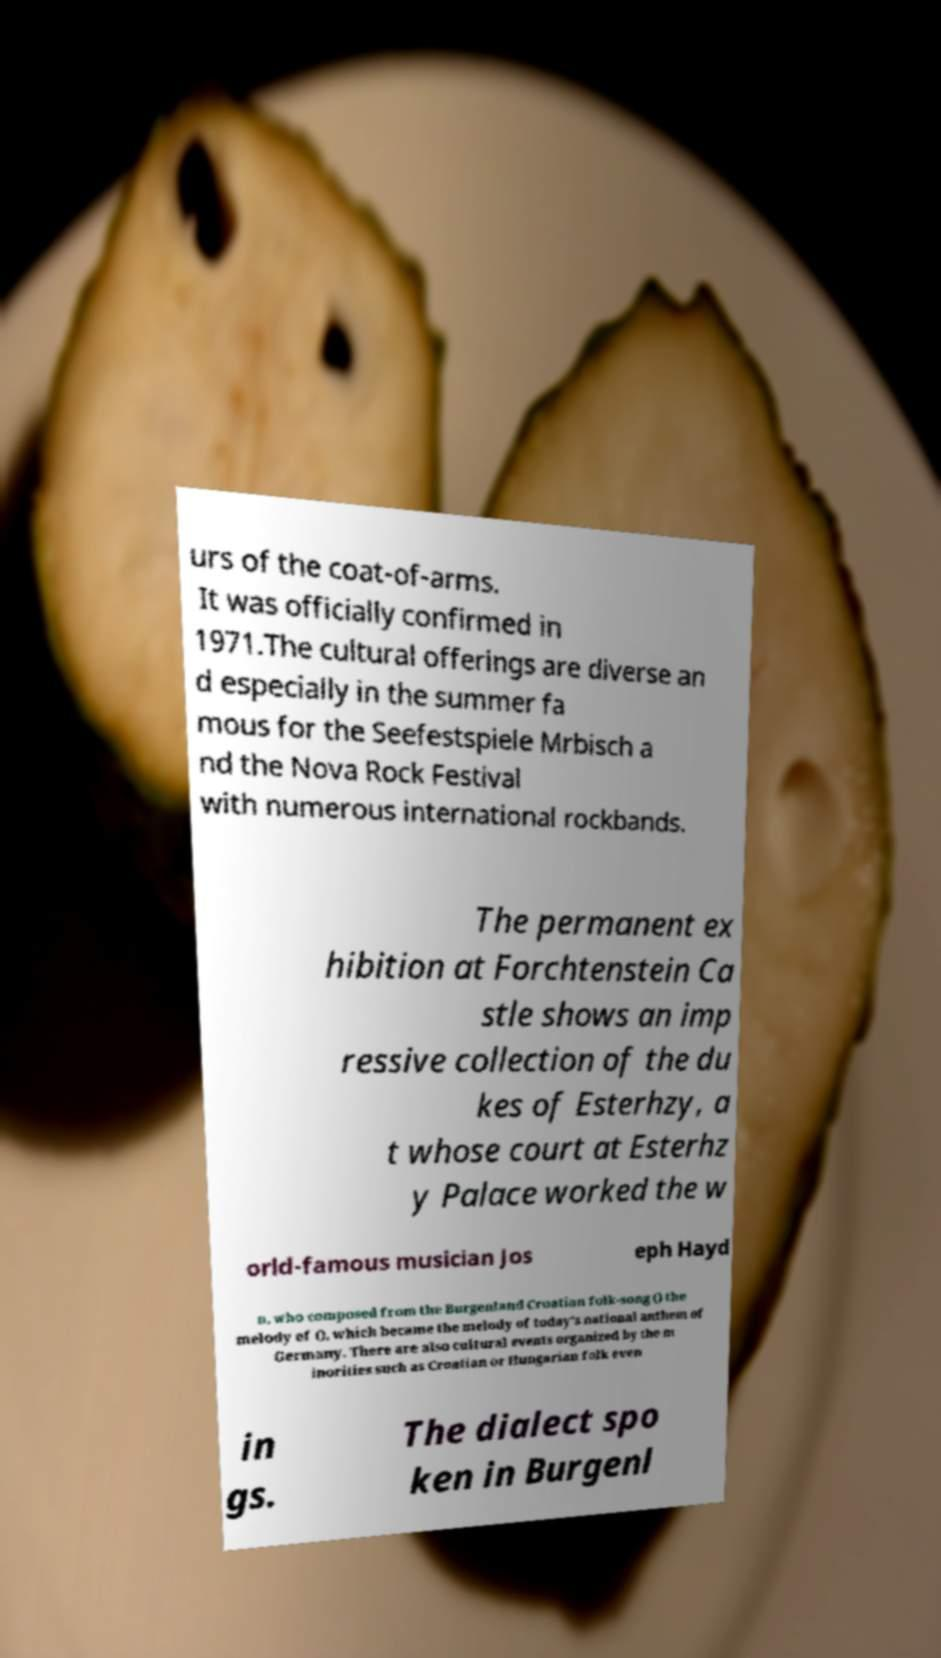For documentation purposes, I need the text within this image transcribed. Could you provide that? urs of the coat-of-arms. It was officially confirmed in 1971.The cultural offerings are diverse an d especially in the summer fa mous for the Seefestspiele Mrbisch a nd the Nova Rock Festival with numerous international rockbands. The permanent ex hibition at Forchtenstein Ca stle shows an imp ressive collection of the du kes of Esterhzy, a t whose court at Esterhz y Palace worked the w orld-famous musician Jos eph Hayd n, who composed from the Burgenland Croatian folk-song () the melody of (), which became the melody of today's national anthem of Germany. There are also cultural events organized by the m inorities such as Croatian or Hungarian folk even in gs. The dialect spo ken in Burgenl 